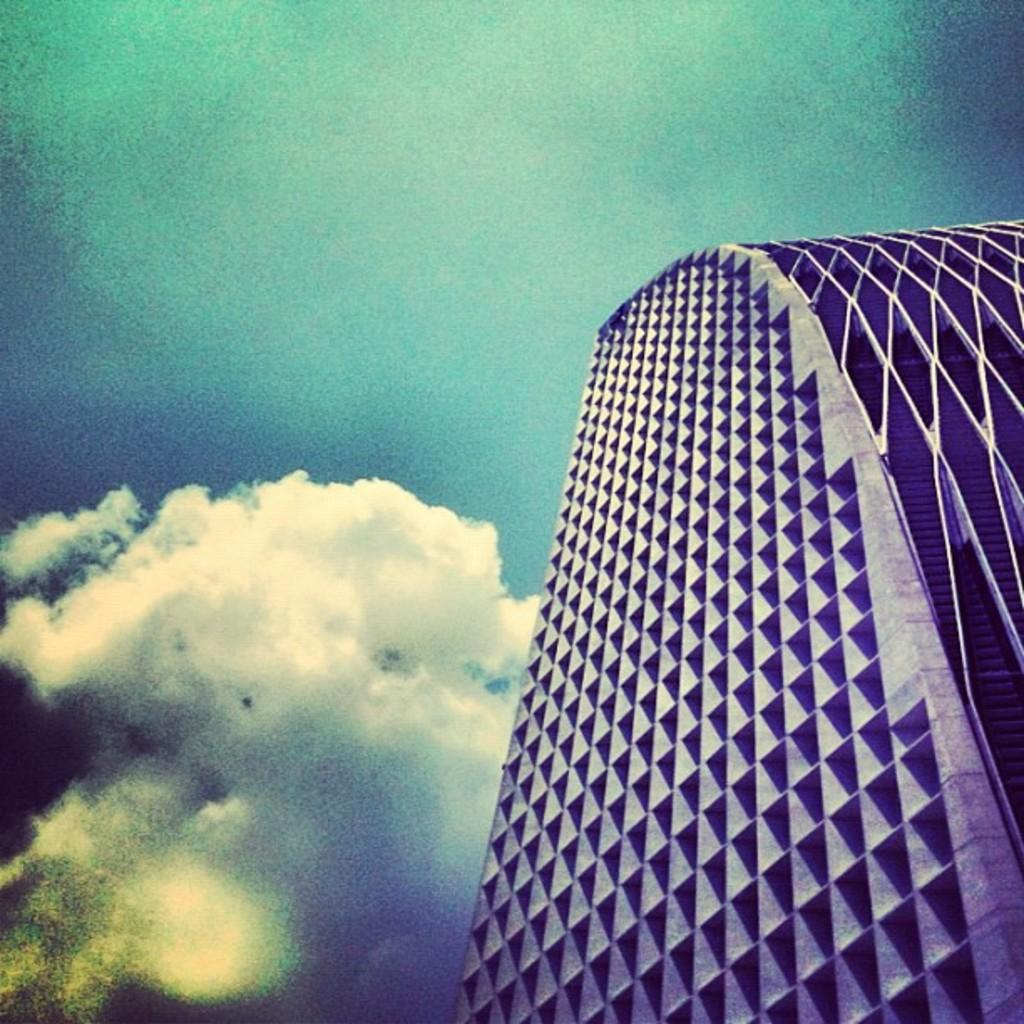What is the main structure visible in the foreground of the image? There is a skyscraper in the foreground of the image. On which side of the image is the skyscraper located? The skyscraper is on the right side of the image. What is visible at the top of the image? The sky is visible at the top of the image. What can be observed in the sky? There are clouds in the sky. Can you see the vein of the skyscraper in the image? There is no vein present in the image, as the term "vein" typically refers to a blood vessel in living organisms and is not applicable to a skyscraper. 